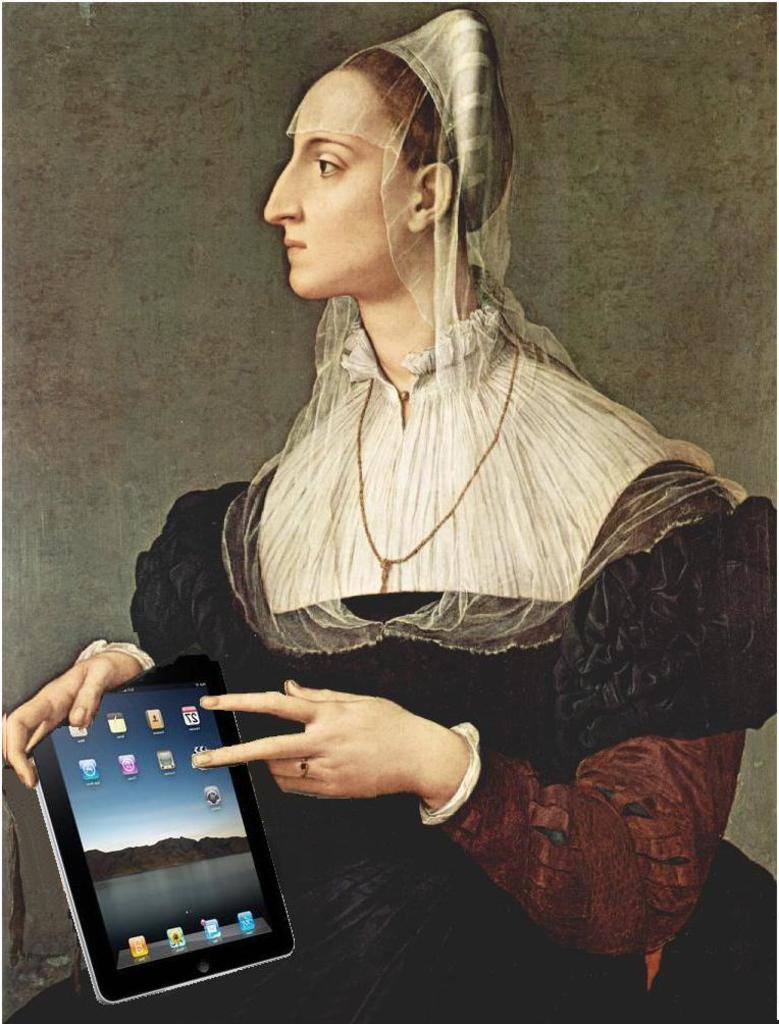In one or two sentences, can you explain what this image depicts? In the center of the image there is a depiction of a lady holding an ipad. 